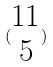<formula> <loc_0><loc_0><loc_500><loc_500>( \begin{matrix} 1 1 \\ 5 \end{matrix} )</formula> 